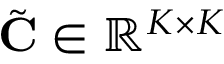Convert formula to latex. <formula><loc_0><loc_0><loc_500><loc_500>\tilde { C } \in \mathbb { R } ^ { K \times K }</formula> 